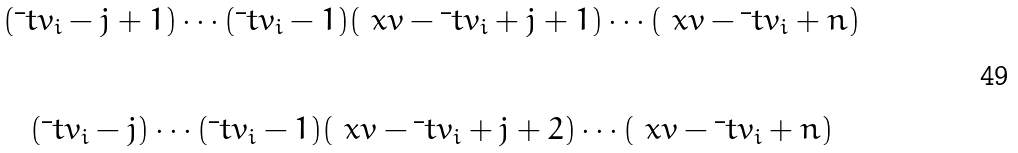<formula> <loc_0><loc_0><loc_500><loc_500>\begin{matrix} \\ ( \bar { \ } t v _ { i } - j + 1 ) \cdots ( \bar { \ } t v _ { i } - 1 ) ( \ x v - \bar { \ } t v _ { i } + j + 1 ) \cdots ( \ x v - \bar { \ } t v _ { i } + n ) \\ \\ \\ ( \bar { \ } t v _ { i } - j ) \cdots ( \bar { \ } t v _ { i } - 1 ) ( \ x v - \bar { \ } t v _ { i } + j + 2 ) \cdots ( \ x v - \bar { \ } t v _ { i } + n ) \\ \\ \end{matrix}</formula> 